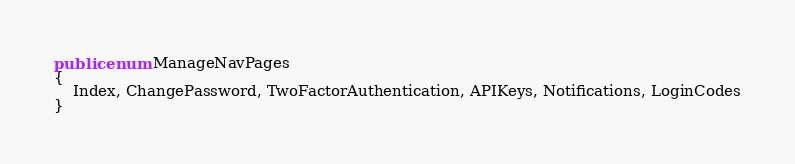Convert code to text. <code><loc_0><loc_0><loc_500><loc_500><_C#_>public enum ManageNavPages
{
    Index, ChangePassword, TwoFactorAuthentication, APIKeys, Notifications, LoginCodes
}
</code> 